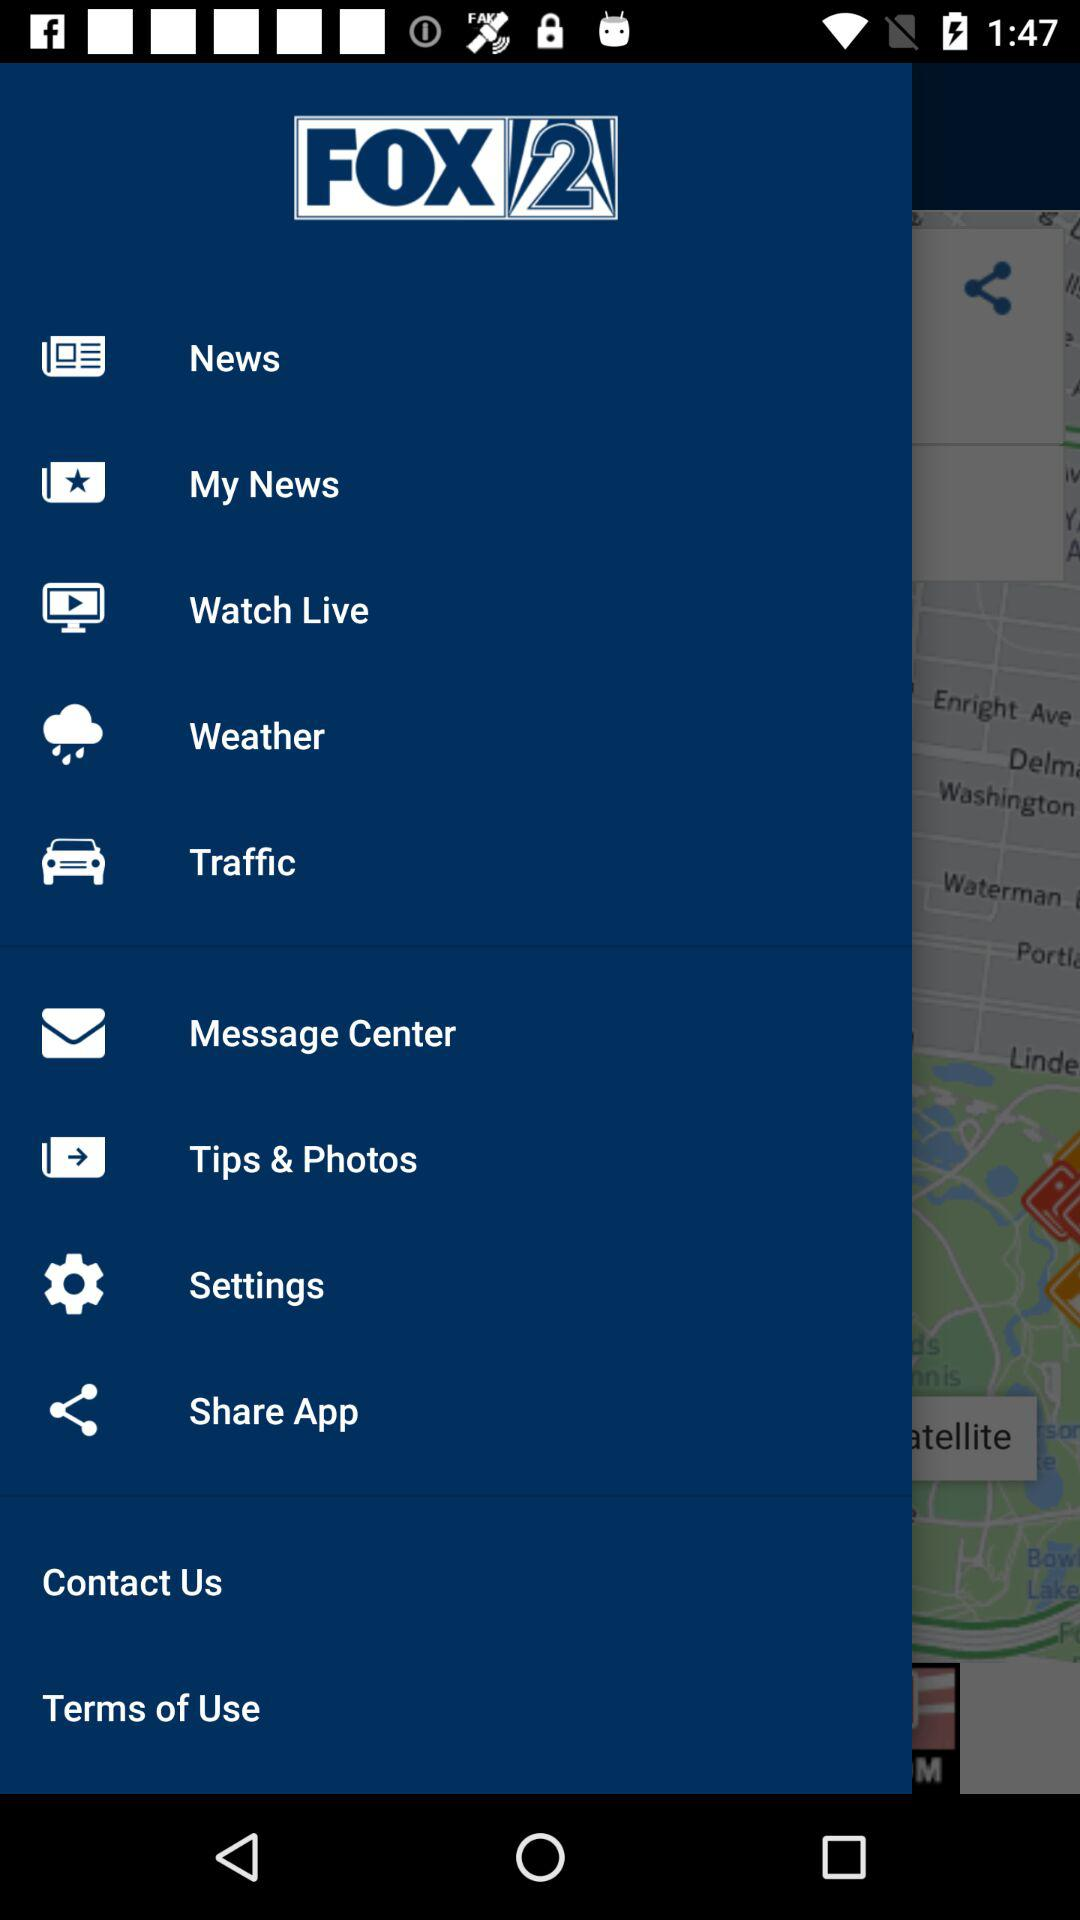When was the last message posted?
When the provided information is insufficient, respond with <no answer>. <no answer> 